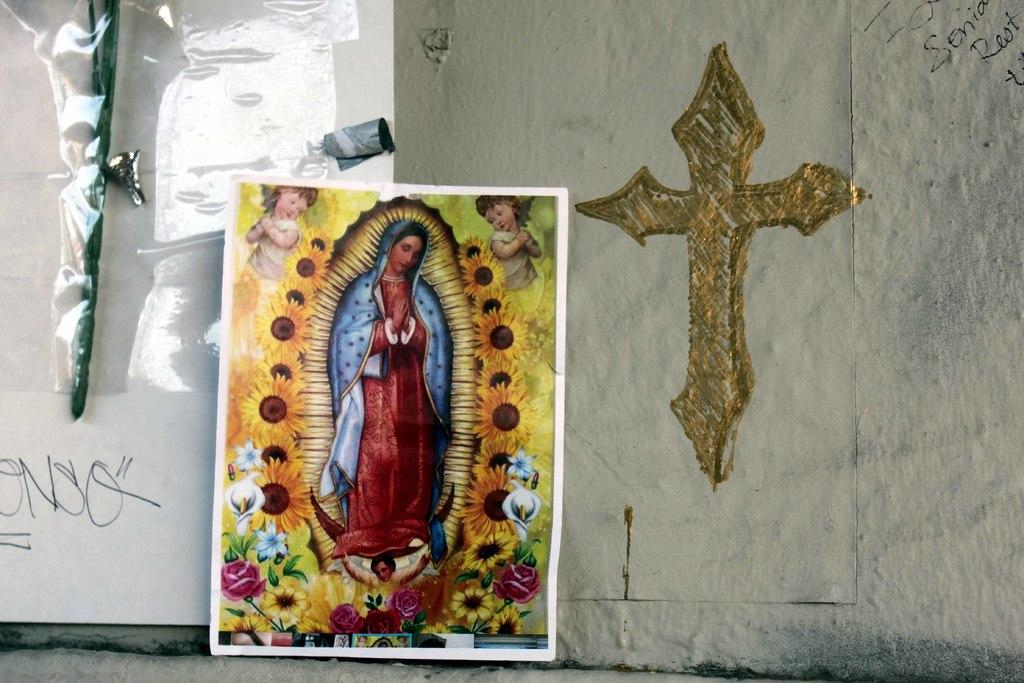<image>
Summarize the visual content of the image. ONSO is written on the wall next a picture of Mary and a cross 